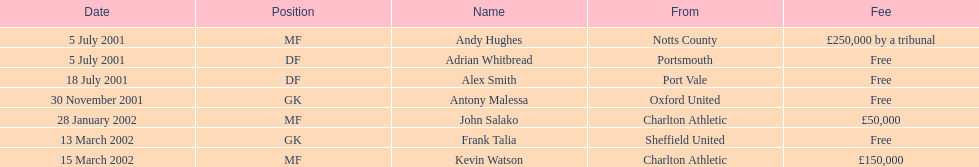What was the transfer fee to transfer kevin watson? £150,000. 